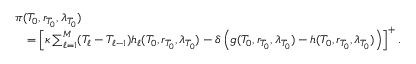Convert formula to latex. <formula><loc_0><loc_0><loc_500><loc_500>\begin{array} { r l } & { \pi ( T _ { 0 } , r _ { T _ { 0 } } , \lambda _ { T _ { 0 } } ) } \\ & { \quad = \left [ \kappa \sum _ { \ell = 1 } ^ { M } ( T _ { \ell } - T _ { \ell - 1 } ) h _ { \ell } ( T _ { 0 } , r _ { T _ { 0 } } , \lambda _ { T _ { 0 } } ) - \delta \left ( g ( T _ { 0 } , r _ { T _ { 0 } } , \lambda _ { T _ { 0 } } ) - h ( T _ { 0 } , r _ { T _ { 0 } } , \lambda _ { T _ { 0 } } ) \right ) \right ] ^ { + } . } \end{array}</formula> 